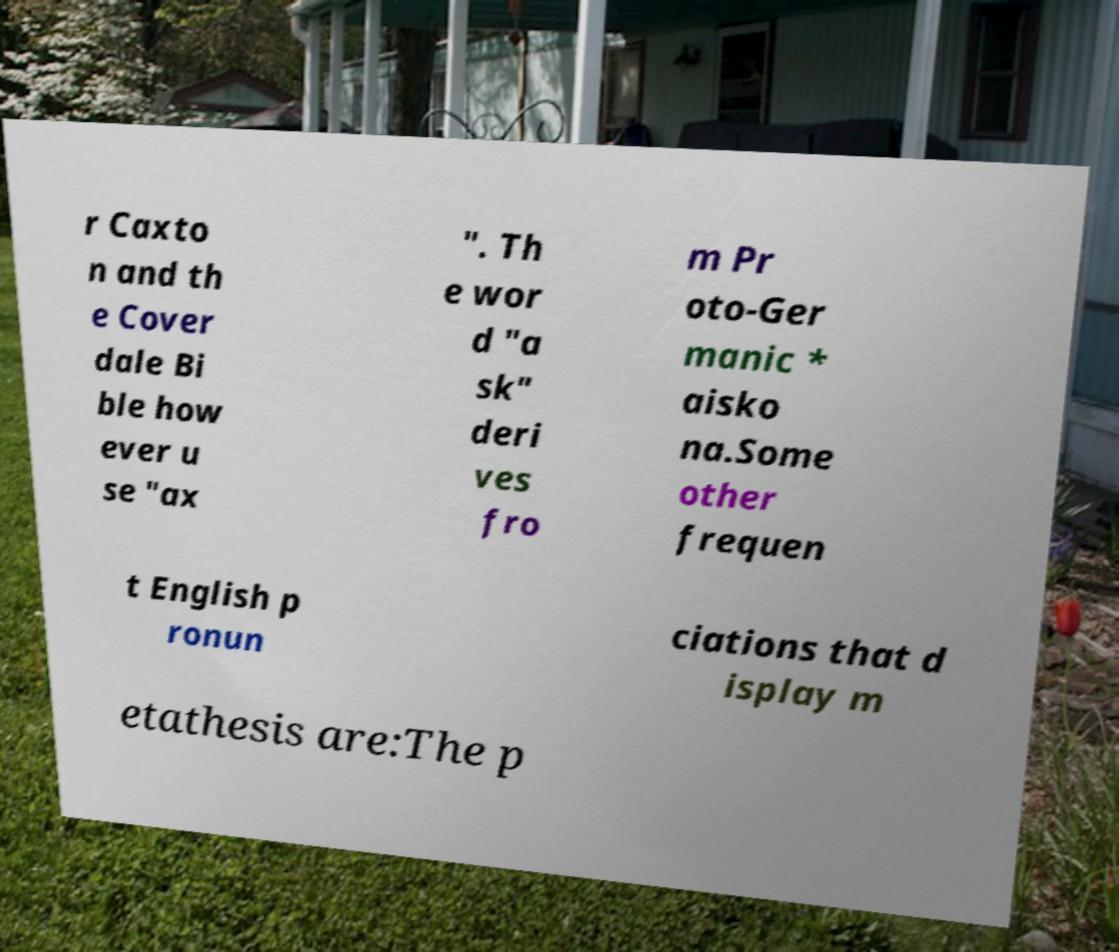Could you extract and type out the text from this image? r Caxto n and th e Cover dale Bi ble how ever u se "ax ". Th e wor d "a sk" deri ves fro m Pr oto-Ger manic * aisko na.Some other frequen t English p ronun ciations that d isplay m etathesis are:The p 